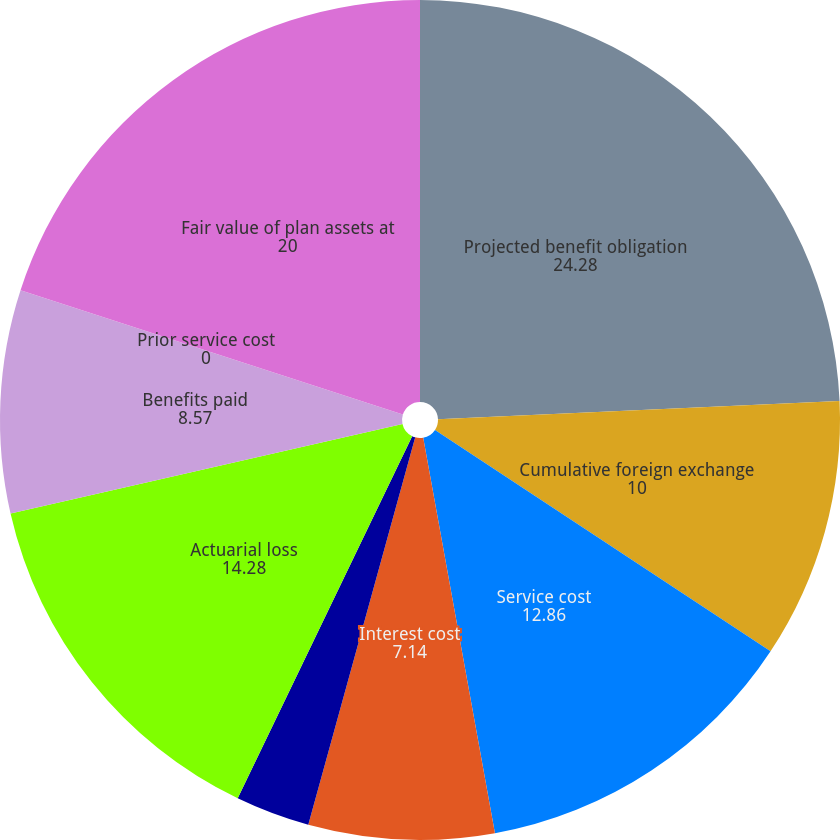Convert chart. <chart><loc_0><loc_0><loc_500><loc_500><pie_chart><fcel>Projected benefit obligation<fcel>Cumulative foreign exchange<fcel>Service cost<fcel>Interest cost<fcel>Plan participants<fcel>Actuarial loss<fcel>Benefits paid<fcel>Prior service cost<fcel>Fair value of plan assets at<nl><fcel>24.28%<fcel>10.0%<fcel>12.86%<fcel>7.14%<fcel>2.86%<fcel>14.28%<fcel>8.57%<fcel>0.0%<fcel>20.0%<nl></chart> 